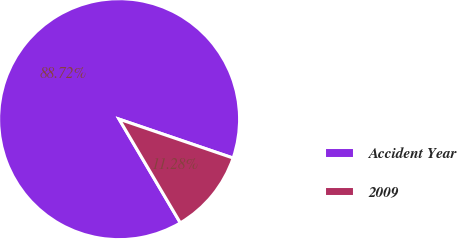Convert chart. <chart><loc_0><loc_0><loc_500><loc_500><pie_chart><fcel>Accident Year<fcel>2009<nl><fcel>88.72%<fcel>11.28%<nl></chart> 